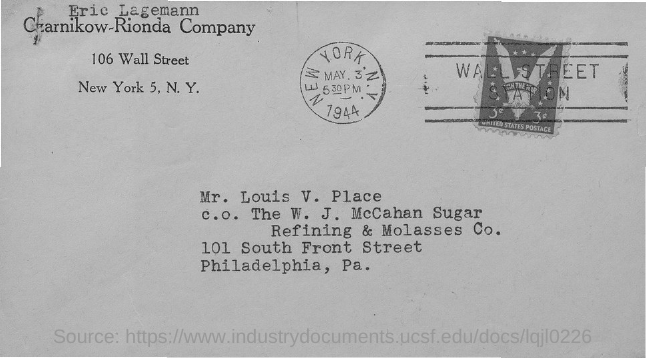Draw attention to some important aspects in this diagram. The letter is addressed to MR. LOUIS V. PLACE. The letter is from a person named Eric Lagemann. On May 3, 1944, the date was recorded. The city name that appears on the round-shaped stamp is New York. 